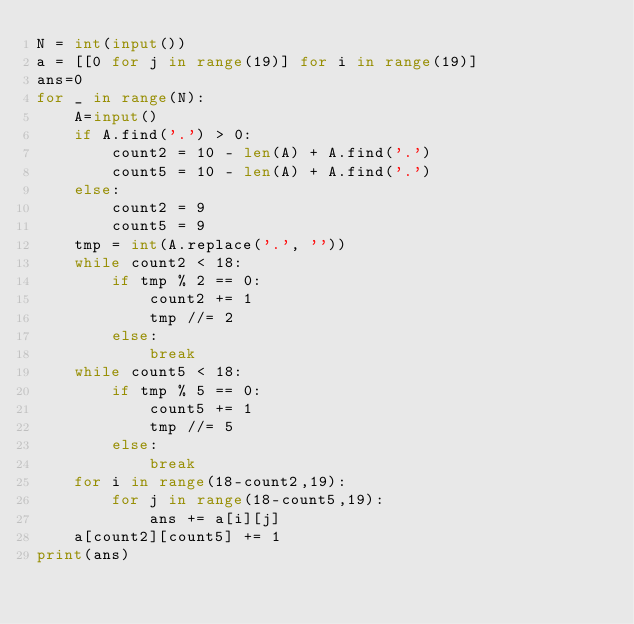Convert code to text. <code><loc_0><loc_0><loc_500><loc_500><_Python_>N = int(input())
a = [[0 for j in range(19)] for i in range(19)]
ans=0
for _ in range(N):
    A=input()
    if A.find('.') > 0:
        count2 = 10 - len(A) + A.find('.')
        count5 = 10 - len(A) + A.find('.')
    else:
        count2 = 9
        count5 = 9
    tmp = int(A.replace('.', ''))
    while count2 < 18:
        if tmp % 2 == 0:
            count2 += 1
            tmp //= 2
        else:
            break
    while count5 < 18:
        if tmp % 5 == 0:
            count5 += 1
            tmp //= 5
        else:
            break
    for i in range(18-count2,19):
        for j in range(18-count5,19):
            ans += a[i][j]
    a[count2][count5] += 1
print(ans)
</code> 